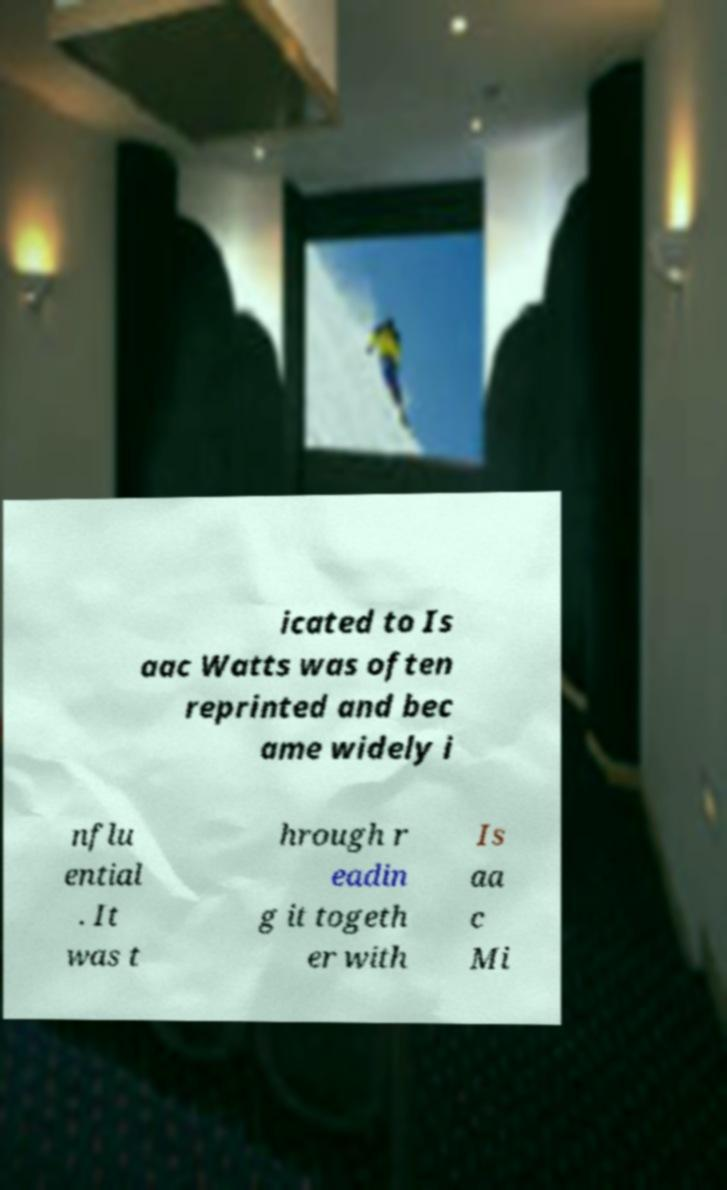Please identify and transcribe the text found in this image. icated to Is aac Watts was often reprinted and bec ame widely i nflu ential . It was t hrough r eadin g it togeth er with Is aa c Mi 